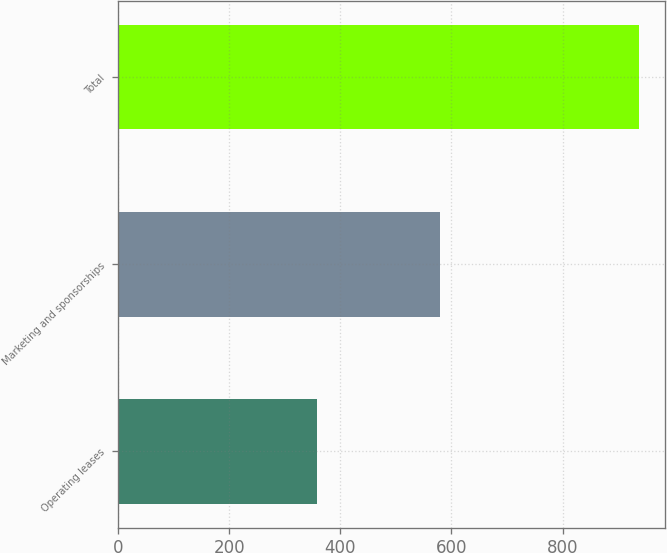Convert chart to OTSL. <chart><loc_0><loc_0><loc_500><loc_500><bar_chart><fcel>Operating leases<fcel>Marketing and sponsorships<fcel>Total<nl><fcel>357<fcel>580<fcel>937<nl></chart> 